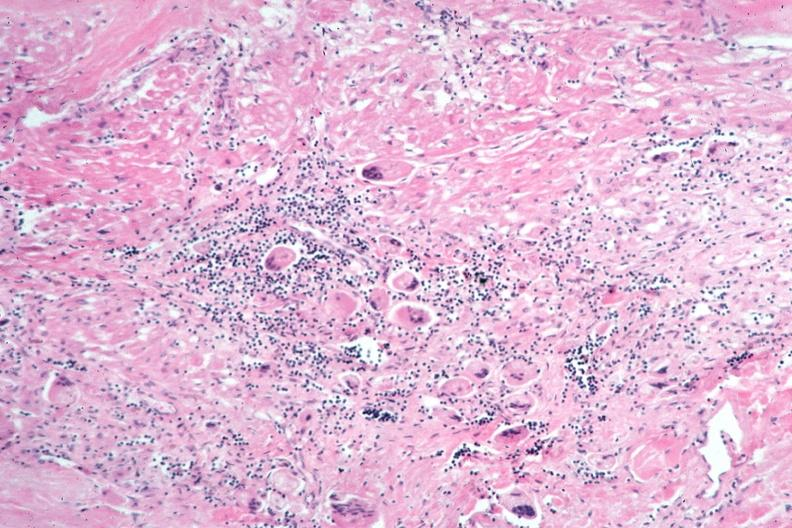where is this?
Answer the question using a single word or phrase. Lung 